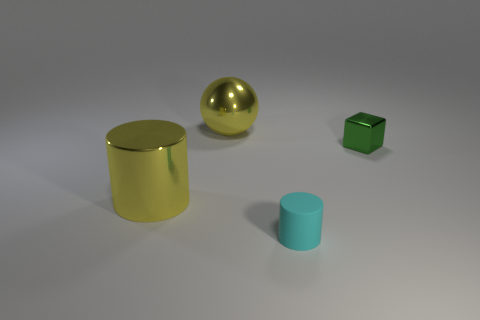Add 4 tiny blue things. How many objects exist? 8 Subtract all spheres. How many objects are left? 3 Subtract all big yellow metal objects. Subtract all big yellow things. How many objects are left? 0 Add 4 small cylinders. How many small cylinders are left? 5 Add 3 tiny cyan things. How many tiny cyan things exist? 4 Subtract 1 green cubes. How many objects are left? 3 